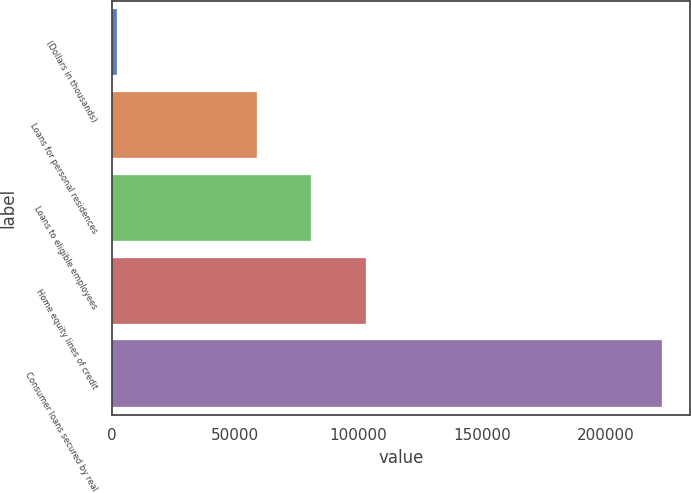<chart> <loc_0><loc_0><loc_500><loc_500><bar_chart><fcel>(Dollars in thousands)<fcel>Loans for personal residences<fcel>Loans to eligible employees<fcel>Home equity lines of credit<fcel>Consumer loans secured by real<nl><fcel>2008<fcel>58702<fcel>80802.4<fcel>102903<fcel>223012<nl></chart> 